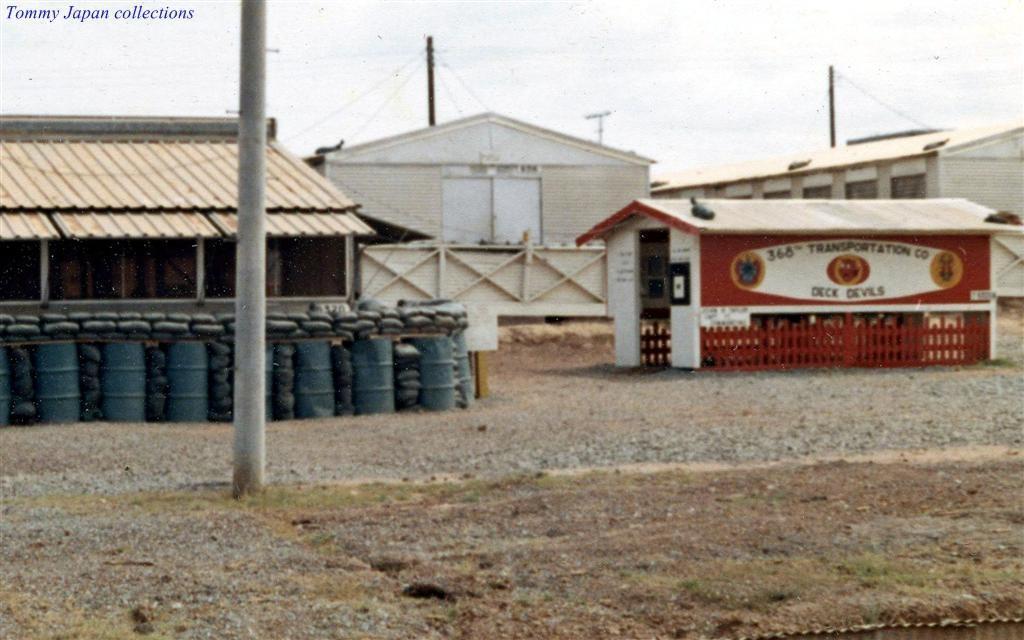How would you summarize this image in a sentence or two? In this image I can see few buildings. In front I can see few drums in blue and black color, I can also see few poles. Background the sky is in white color. 